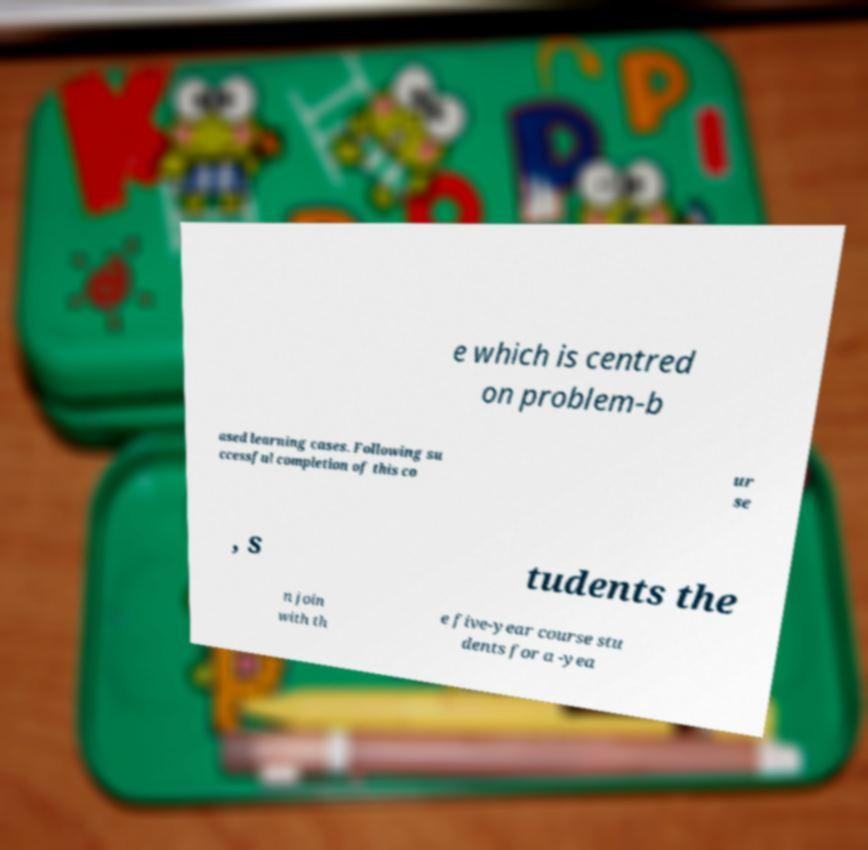Could you assist in decoding the text presented in this image and type it out clearly? e which is centred on problem-b ased learning cases. Following su ccessful completion of this co ur se , s tudents the n join with th e five-year course stu dents for a -yea 